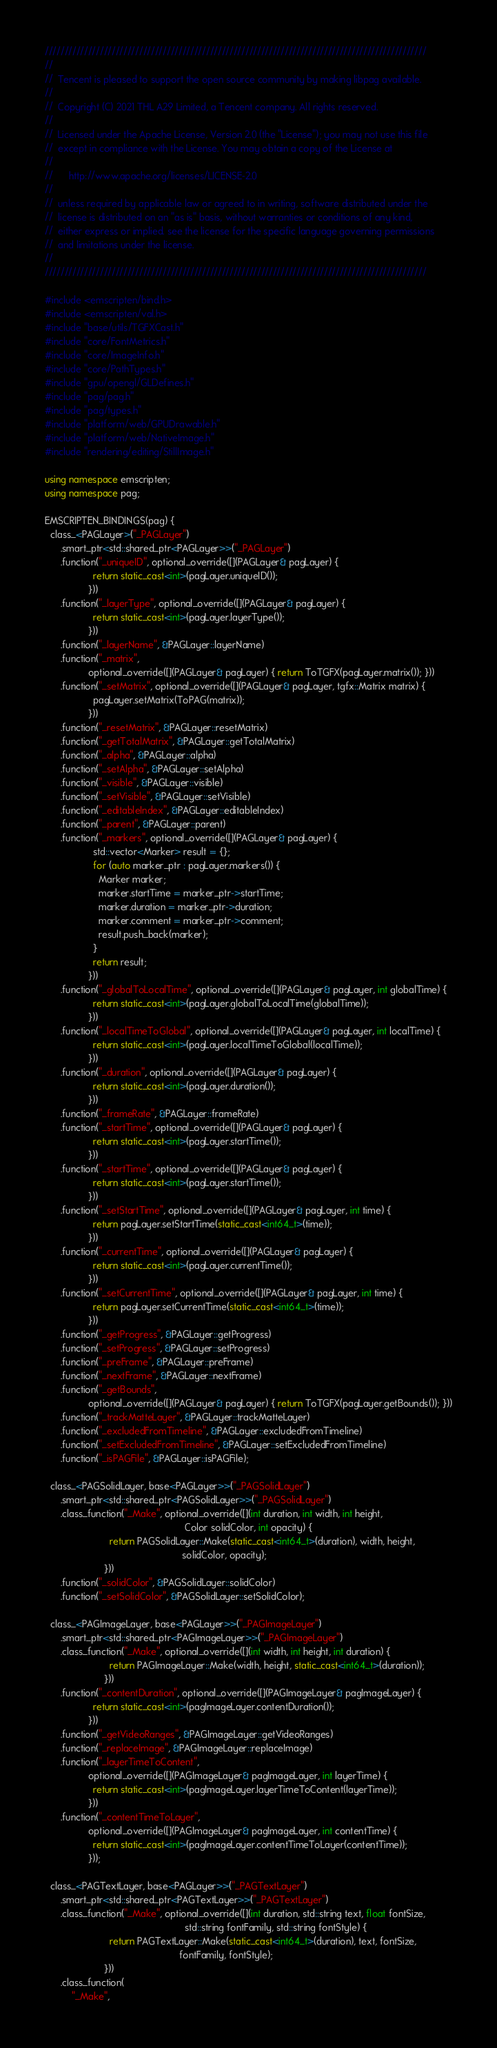Convert code to text. <code><loc_0><loc_0><loc_500><loc_500><_C++_>/////////////////////////////////////////////////////////////////////////////////////////////////
//
//  Tencent is pleased to support the open source community by making libpag available.
//
//  Copyright (C) 2021 THL A29 Limited, a Tencent company. All rights reserved.
//
//  Licensed under the Apache License, Version 2.0 (the "License"); you may not use this file
//  except in compliance with the License. You may obtain a copy of the License at
//
//      http://www.apache.org/licenses/LICENSE-2.0
//
//  unless required by applicable law or agreed to in writing, software distributed under the
//  license is distributed on an "as is" basis, without warranties or conditions of any kind,
//  either express or implied. see the license for the specific language governing permissions
//  and limitations under the license.
//
/////////////////////////////////////////////////////////////////////////////////////////////////

#include <emscripten/bind.h>
#include <emscripten/val.h>
#include "base/utils/TGFXCast.h"
#include "core/FontMetrics.h"
#include "core/ImageInfo.h"
#include "core/PathTypes.h"
#include "gpu/opengl/GLDefines.h"
#include "pag/pag.h"
#include "pag/types.h"
#include "platform/web/GPUDrawable.h"
#include "platform/web/NativeImage.h"
#include "rendering/editing/StillImage.h"

using namespace emscripten;
using namespace pag;

EMSCRIPTEN_BINDINGS(pag) {
  class_<PAGLayer>("_PAGLayer")
      .smart_ptr<std::shared_ptr<PAGLayer>>("_PAGLayer")
      .function("_uniqueID", optional_override([](PAGLayer& pagLayer) {
                  return static_cast<int>(pagLayer.uniqueID());
                }))
      .function("_layerType", optional_override([](PAGLayer& pagLayer) {
                  return static_cast<int>(pagLayer.layerType());
                }))
      .function("_layerName", &PAGLayer::layerName)
      .function("_matrix",
                optional_override([](PAGLayer& pagLayer) { return ToTGFX(pagLayer.matrix()); }))
      .function("_setMatrix", optional_override([](PAGLayer& pagLayer, tgfx::Matrix matrix) {
                  pagLayer.setMatrix(ToPAG(matrix));
                }))
      .function("_resetMatrix", &PAGLayer::resetMatrix)
      .function("_getTotalMatrix", &PAGLayer::getTotalMatrix)
      .function("_alpha", &PAGLayer::alpha)
      .function("_setAlpha", &PAGLayer::setAlpha)
      .function("_visible", &PAGLayer::visible)
      .function("_setVisible", &PAGLayer::setVisible)
      .function("_editableIndex", &PAGLayer::editableIndex)
      .function("_parent", &PAGLayer::parent)
      .function("_markers", optional_override([](PAGLayer& pagLayer) {
                  std::vector<Marker> result = {};
                  for (auto marker_ptr : pagLayer.markers()) {
                    Marker marker;
                    marker.startTime = marker_ptr->startTime;
                    marker.duration = marker_ptr->duration;
                    marker.comment = marker_ptr->comment;
                    result.push_back(marker);
                  }
                  return result;
                }))
      .function("_globalToLocalTime", optional_override([](PAGLayer& pagLayer, int globalTime) {
                  return static_cast<int>(pagLayer.globalToLocalTime(globalTime));
                }))
      .function("_localTimeToGlobal", optional_override([](PAGLayer& pagLayer, int localTime) {
                  return static_cast<int>(pagLayer.localTimeToGlobal(localTime));
                }))
      .function("_duration", optional_override([](PAGLayer& pagLayer) {
                  return static_cast<int>(pagLayer.duration());
                }))
      .function("_frameRate", &PAGLayer::frameRate)
      .function("_startTime", optional_override([](PAGLayer& pagLayer) {
                  return static_cast<int>(pagLayer.startTime());
                }))
      .function("_startTime", optional_override([](PAGLayer& pagLayer) {
                  return static_cast<int>(pagLayer.startTime());
                }))
      .function("_setStartTime", optional_override([](PAGLayer& pagLayer, int time) {
                  return pagLayer.setStartTime(static_cast<int64_t>(time));
                }))
      .function("_currentTime", optional_override([](PAGLayer& pagLayer) {
                  return static_cast<int>(pagLayer.currentTime());
                }))
      .function("_setCurrentTime", optional_override([](PAGLayer& pagLayer, int time) {
                  return pagLayer.setCurrentTime(static_cast<int64_t>(time));
                }))
      .function("_getProgress", &PAGLayer::getProgress)
      .function("_setProgress", &PAGLayer::setProgress)
      .function("_preFrame", &PAGLayer::preFrame)
      .function("_nextFrame", &PAGLayer::nextFrame)
      .function("_getBounds",
                optional_override([](PAGLayer& pagLayer) { return ToTGFX(pagLayer.getBounds()); }))
      .function("_trackMatteLayer", &PAGLayer::trackMatteLayer)
      .function("_excludedFromTimeline", &PAGLayer::excludedFromTimeline)
      .function("_setExcludedFromTimeline", &PAGLayer::setExcludedFromTimeline)
      .function("_isPAGFile", &PAGLayer::isPAGFile);

  class_<PAGSolidLayer, base<PAGLayer>>("_PAGSolidLayer")
      .smart_ptr<std::shared_ptr<PAGSolidLayer>>("_PAGSolidLayer")
      .class_function("_Make", optional_override([](int duration, int width, int height,
                                                    Color solidColor, int opacity) {
                        return PAGSolidLayer::Make(static_cast<int64_t>(duration), width, height,
                                                   solidColor, opacity);
                      }))
      .function("_solidColor", &PAGSolidLayer::solidColor)
      .function("_setSolidColor", &PAGSolidLayer::setSolidColor);

  class_<PAGImageLayer, base<PAGLayer>>("_PAGImageLayer")
      .smart_ptr<std::shared_ptr<PAGImageLayer>>("_PAGImageLayer")
      .class_function("_Make", optional_override([](int width, int height, int duration) {
                        return PAGImageLayer::Make(width, height, static_cast<int64_t>(duration));
                      }))
      .function("_contentDuration", optional_override([](PAGImageLayer& pagImageLayer) {
                  return static_cast<int>(pagImageLayer.contentDuration());
                }))
      .function("_getVideoRanges", &PAGImageLayer::getVideoRanges)
      .function("_replaceImage", &PAGImageLayer::replaceImage)
      .function("_layerTimeToContent",
                optional_override([](PAGImageLayer& pagImageLayer, int layerTime) {
                  return static_cast<int>(pagImageLayer.layerTimeToContent(layerTime));
                }))
      .function("_contentTimeToLayer",
                optional_override([](PAGImageLayer& pagImageLayer, int contentTime) {
                  return static_cast<int>(pagImageLayer.contentTimeToLayer(contentTime));
                }));

  class_<PAGTextLayer, base<PAGLayer>>("_PAGTextLayer")
      .smart_ptr<std::shared_ptr<PAGTextLayer>>("_PAGTextLayer")
      .class_function("_Make", optional_override([](int duration, std::string text, float fontSize,
                                                    std::string fontFamily, std::string fontStyle) {
                        return PAGTextLayer::Make(static_cast<int64_t>(duration), text, fontSize,
                                                  fontFamily, fontStyle);
                      }))
      .class_function(
          "_Make",</code> 